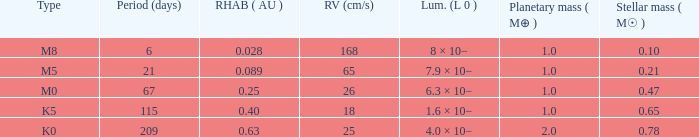What is the total stellar mass of the type m0? 0.47. 